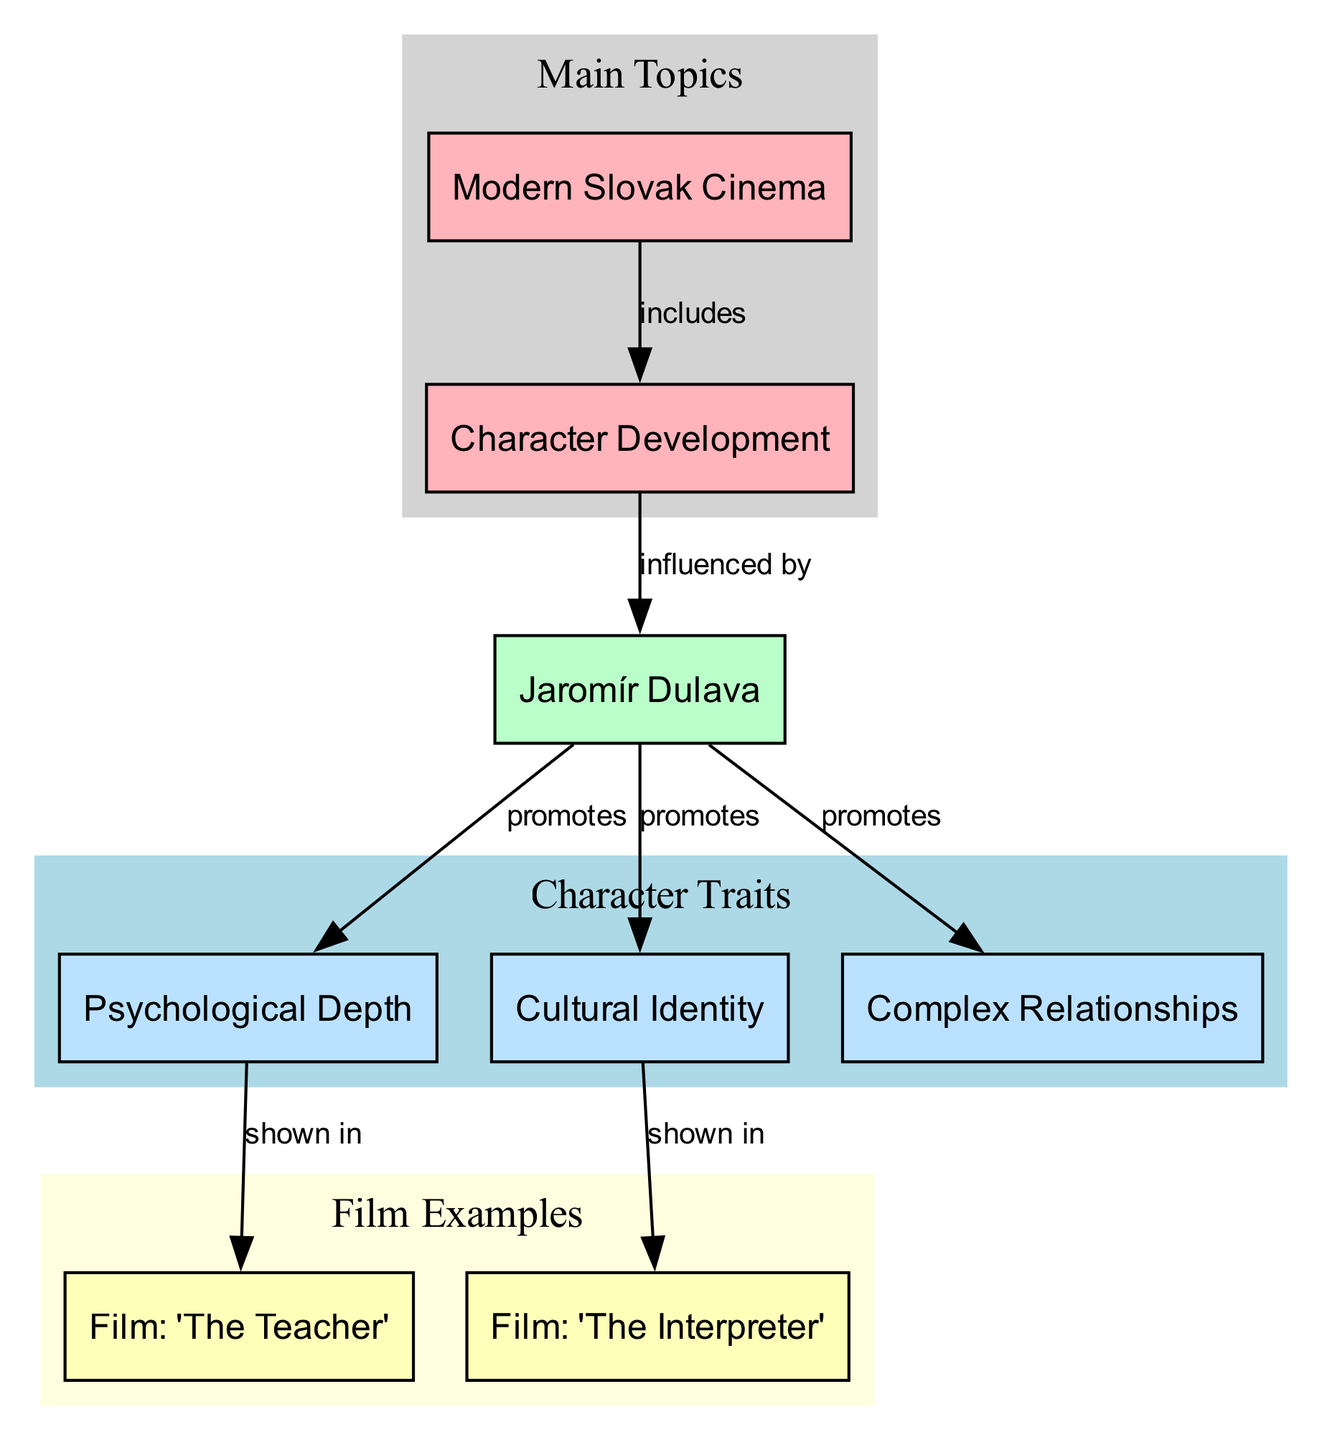What is the main topic related to character development in this diagram? The diagram features nodes that identify "Modern Slovak Cinema" and "Character Development" as main topics. The labels in the main topics clearly indicate their significance.
Answer: Modern Slovak Cinema How many examples of films are shown in the diagram? The diagram includes two nodes that represent films: "The Teacher" and "The Interpreter." By counting these nodes, we find the total number of examples.
Answer: 2 What influences character development in modern Slovak cinema according to the diagram? The diagram specifies that "Jaromír Dulava" is shown to influence character development, which is linked directly to this node. Therefore, the influence of character development in the diagram is attributed to him.
Answer: Jaromír Dulava What character trait is shown in the film “The Interpreter”? The edge connecting "Cultural Identity" to the film node "The Interpreter" indicates that this specific character trait is represented in that film. By following the connections, we can determine the trait associated with each film.
Answer: Cultural Identity Which character traits are promoted by Jaromír Dulava? By analyzing the diagram, we see three edges coming from "Jaromír Dulava" to the nodes representing character traits: Psychological Depth, Cultural Identity, and Complex Relationships, showing that he promotes all three.
Answer: Psychological Depth, Cultural Identity, Complex Relationships What does the edge labeled "shown in" indicate about the film "The Teacher"? The edge labeled "shown in" connects "Psychological Depth" to "The Teacher," indicating that this character trait is featured in that film. This relationship provides clarity on the representation of specific traits in specific films.
Answer: Psychological Depth How is character development related to modern Slovak cinema according to the diagram? The diagram shows a directed edge from "Modern Slovak Cinema" to "Character Development," indicating that character development is a component or includes an aspect of modern Slovak cinema.
Answer: includes Which character trait appears in the film "The Teacher"? The edge connects "Psychological Depth" to "The Teacher," which means this particular trait is depicted in that film specifically. The edge labels clarify this connection directly.
Answer: Psychological Depth Which character trait does not connect to any examples in the diagram? All character traits listed are linked to at least one film example except for "Complex Relationships," which has no direct connection to a film node in the provided edges.
Answer: None 